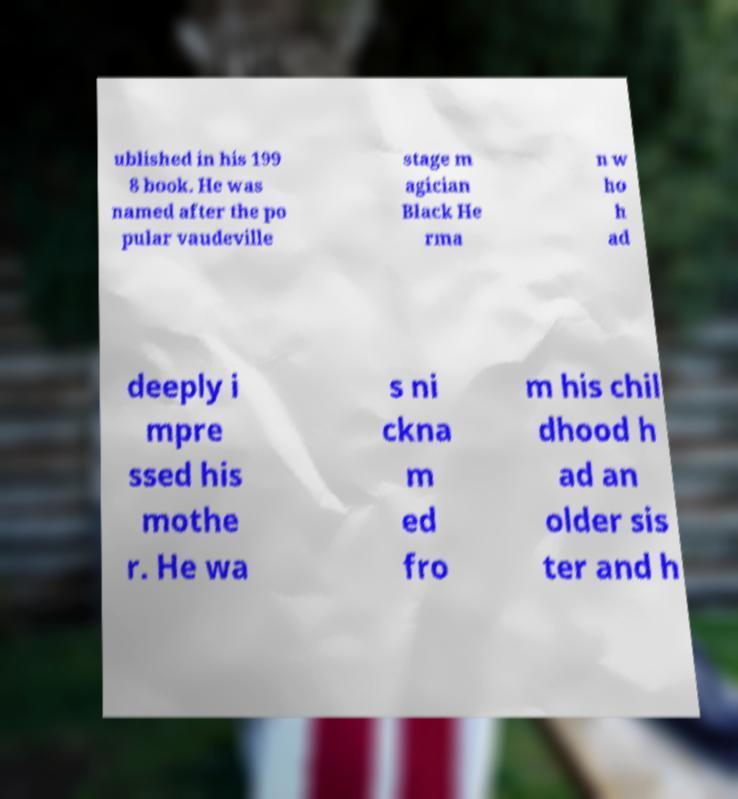For documentation purposes, I need the text within this image transcribed. Could you provide that? ublished in his 199 8 book. He was named after the po pular vaudeville stage m agician Black He rma n w ho h ad deeply i mpre ssed his mothe r. He wa s ni ckna m ed fro m his chil dhood h ad an older sis ter and h 